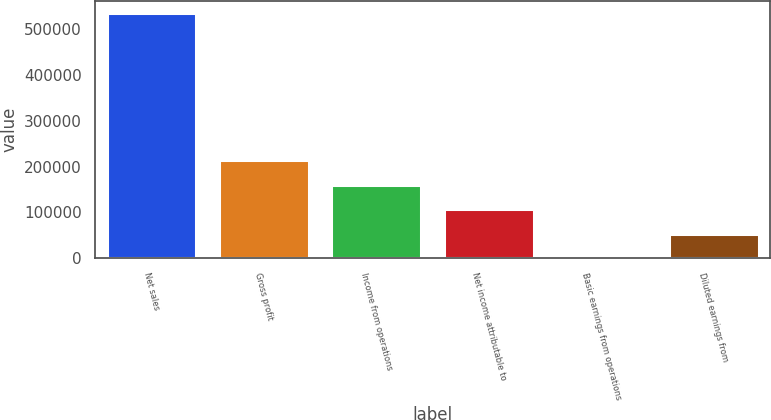<chart> <loc_0><loc_0><loc_500><loc_500><bar_chart><fcel>Net sales<fcel>Gross profit<fcel>Income from operations<fcel>Net income attributable to<fcel>Basic earnings from operations<fcel>Diluted earnings from<nl><fcel>534639<fcel>213856<fcel>160392<fcel>106929<fcel>0.96<fcel>53464.8<nl></chart> 